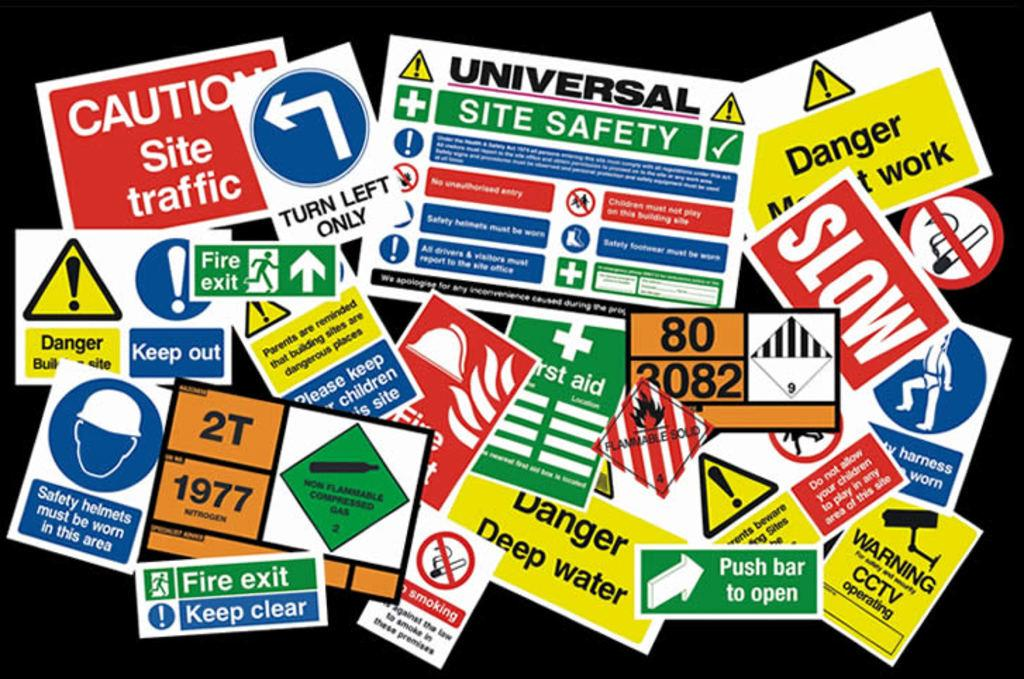Provide a one-sentence caption for the provided image. A bunch of stickers one says to push bar to open. 